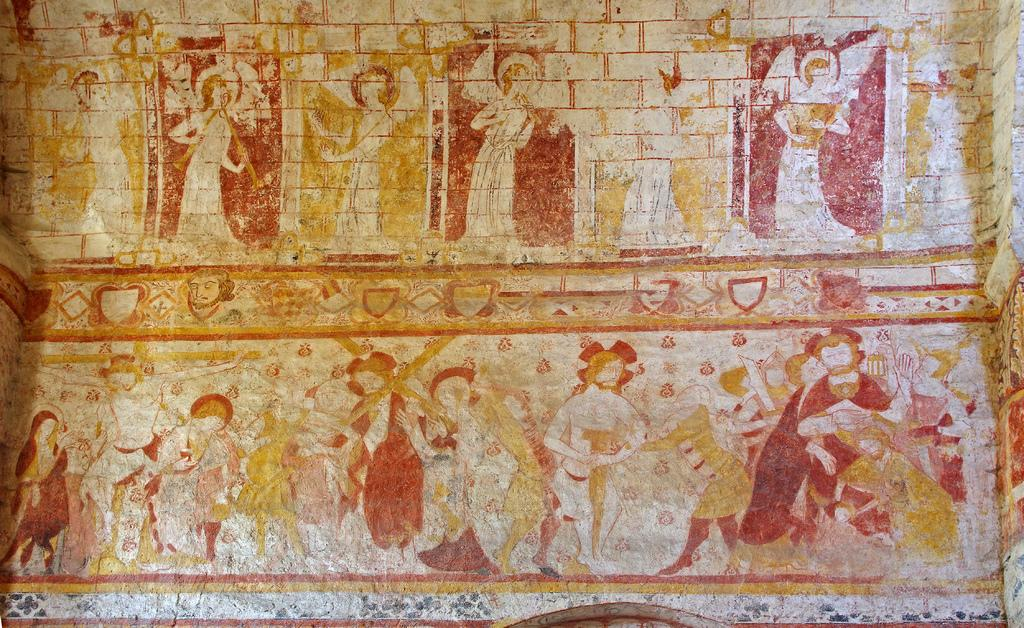What is present on the wall in the image? There are paintings of humans on the wall. Can you describe the paintings in more detail? The paintings depict humans, but the specific details of the paintings cannot be determined from the provided facts. What type of tin can be seen near the paintings on the wall? There is no mention of tin in the image, so it cannot be determined if any is present. 